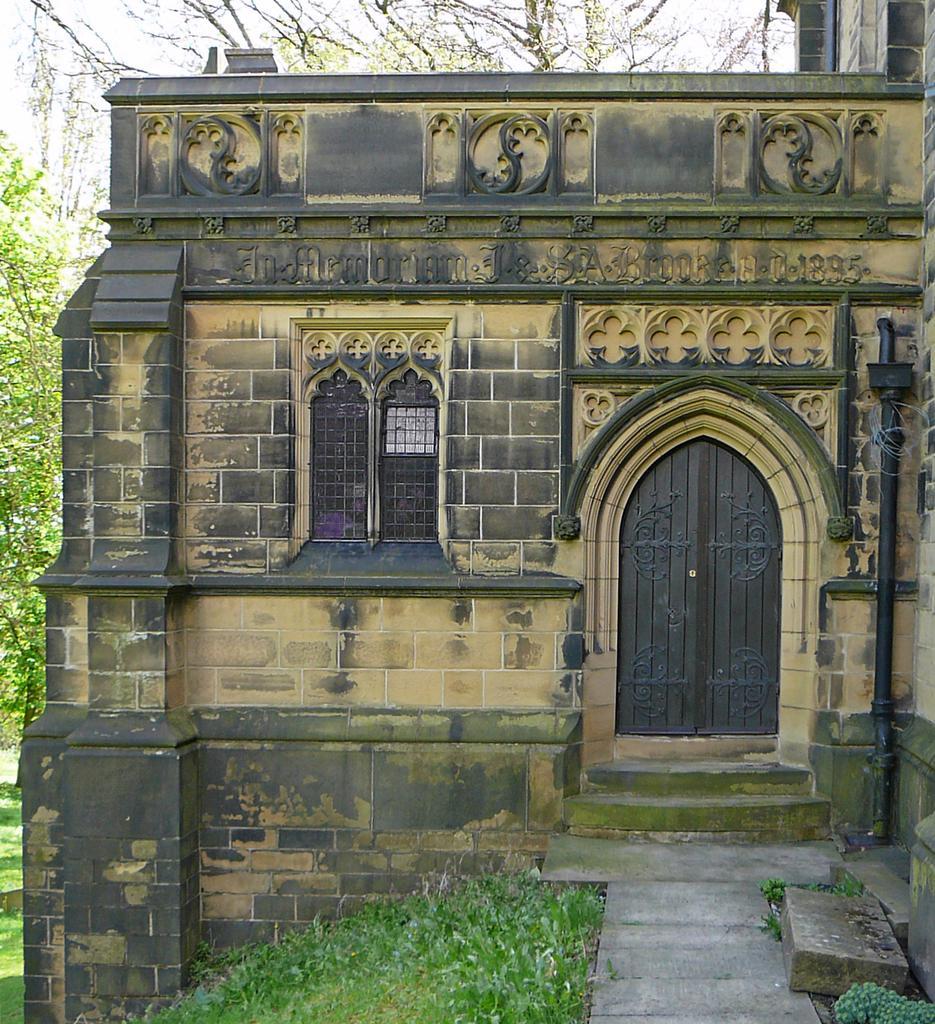How would you summarize this image in a sentence or two? In this picture we can see a building,grass and we can see trees,sky in the background. 